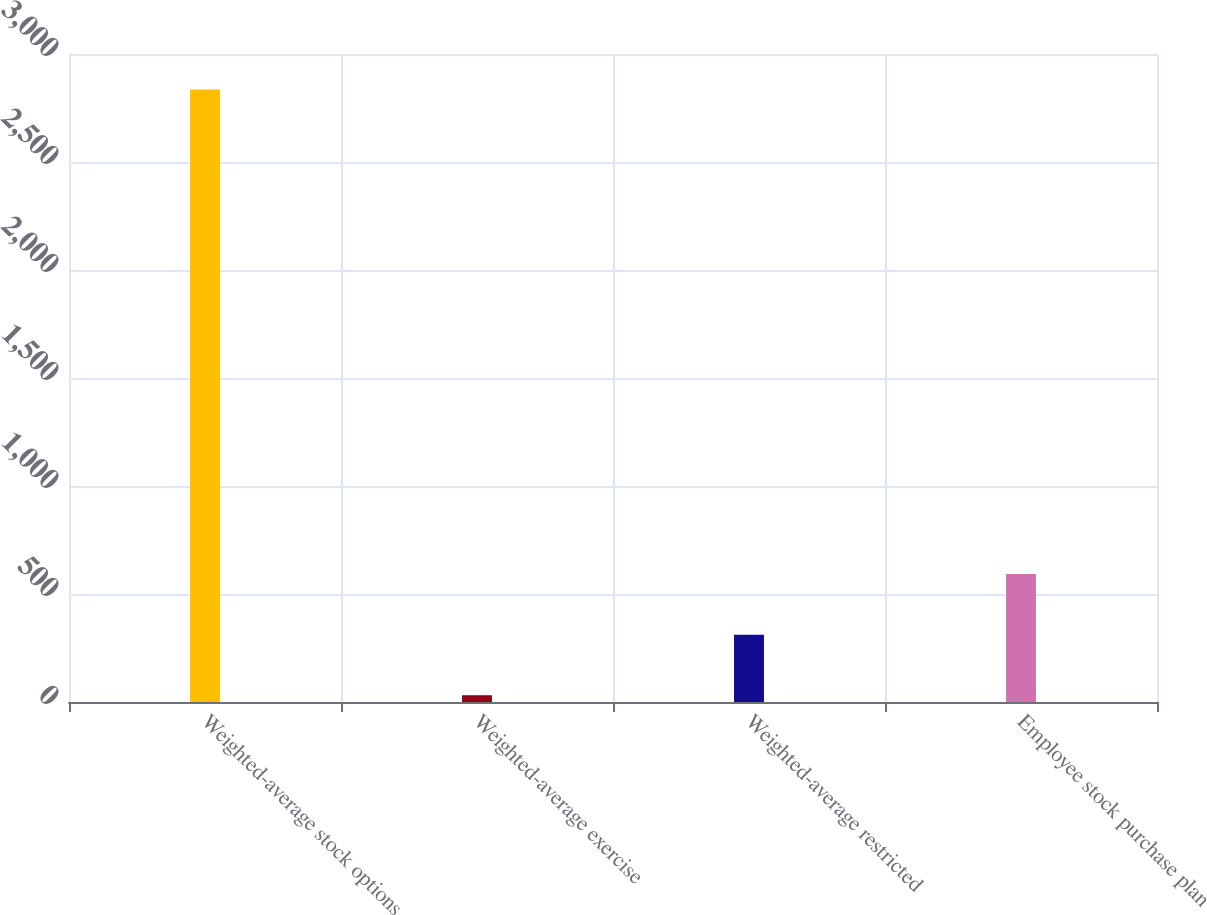Convert chart to OTSL. <chart><loc_0><loc_0><loc_500><loc_500><bar_chart><fcel>Weighted-average stock options<fcel>Weighted-average exercise<fcel>Weighted-average restricted<fcel>Employee stock purchase plan<nl><fcel>2836<fcel>31.32<fcel>311.79<fcel>592.26<nl></chart> 